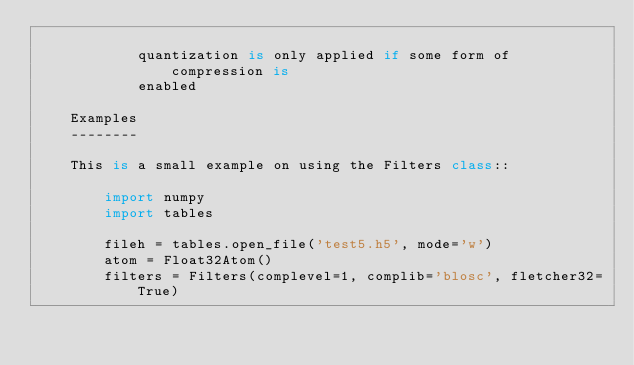Convert code to text. <code><loc_0><loc_0><loc_500><loc_500><_Python_>
            quantization is only applied if some form of compression is
            enabled

    Examples
    --------

    This is a small example on using the Filters class::

        import numpy
        import tables

        fileh = tables.open_file('test5.h5', mode='w')
        atom = Float32Atom()
        filters = Filters(complevel=1, complib='blosc', fletcher32=True)</code> 